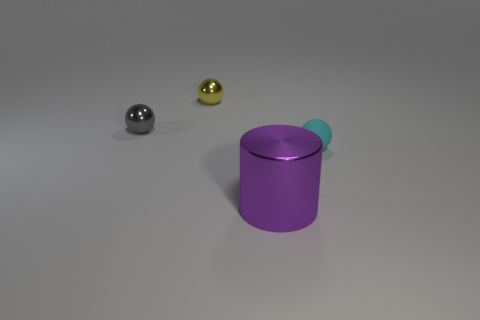Is there a gray metallic object right of the shiny thing in front of the cyan object?
Your answer should be compact. No. Does the rubber sphere have the same color as the cylinder?
Make the answer very short. No. How many other objects are the same shape as the cyan object?
Your answer should be compact. 2. Is the number of cyan balls on the left side of the large purple metallic cylinder greater than the number of gray shiny things that are on the right side of the yellow shiny sphere?
Your response must be concise. No. There is a rubber object that is on the right side of the yellow object; does it have the same size as the metal thing that is in front of the small matte ball?
Your answer should be very brief. No. What is the shape of the yellow metallic thing?
Offer a terse response. Sphere. What color is the cylinder that is the same material as the yellow object?
Give a very brief answer. Purple. Is the material of the big purple object the same as the small ball right of the big metallic cylinder?
Make the answer very short. No. What is the color of the large shiny object?
Your answer should be very brief. Purple. There is a gray sphere that is the same material as the yellow thing; what is its size?
Offer a terse response. Small. 